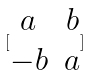<formula> <loc_0><loc_0><loc_500><loc_500>[ \begin{matrix} a & b \\ - b & a \end{matrix} ]</formula> 